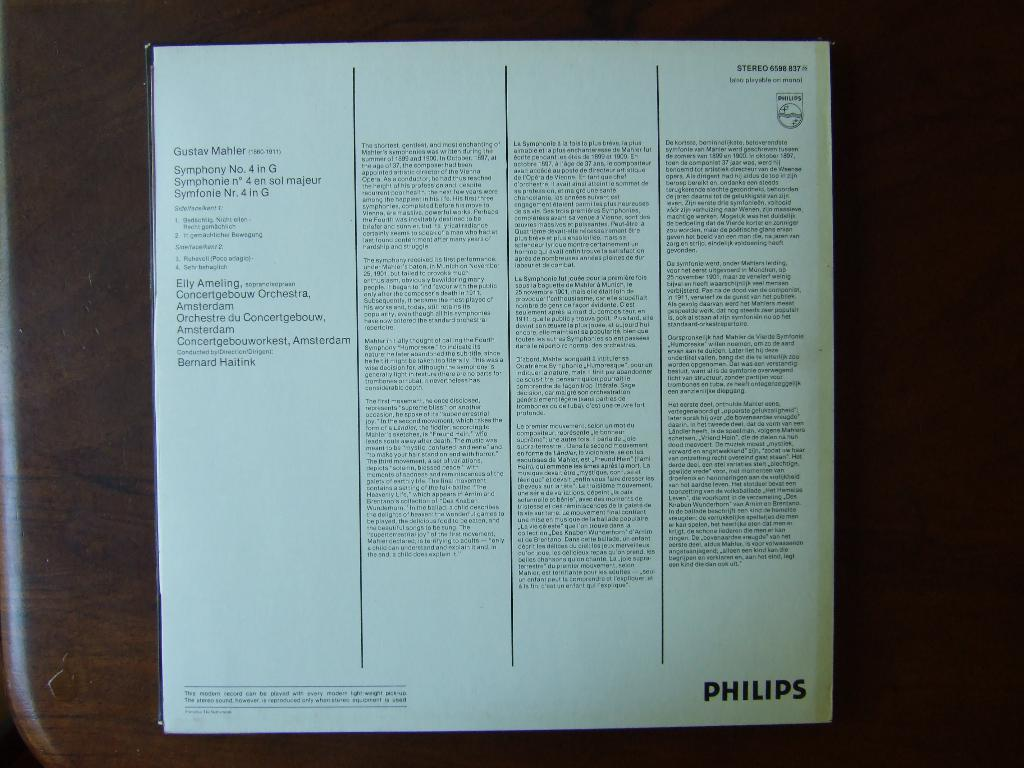<image>
Relay a brief, clear account of the picture shown. a Philips advertisement in a book with many words 